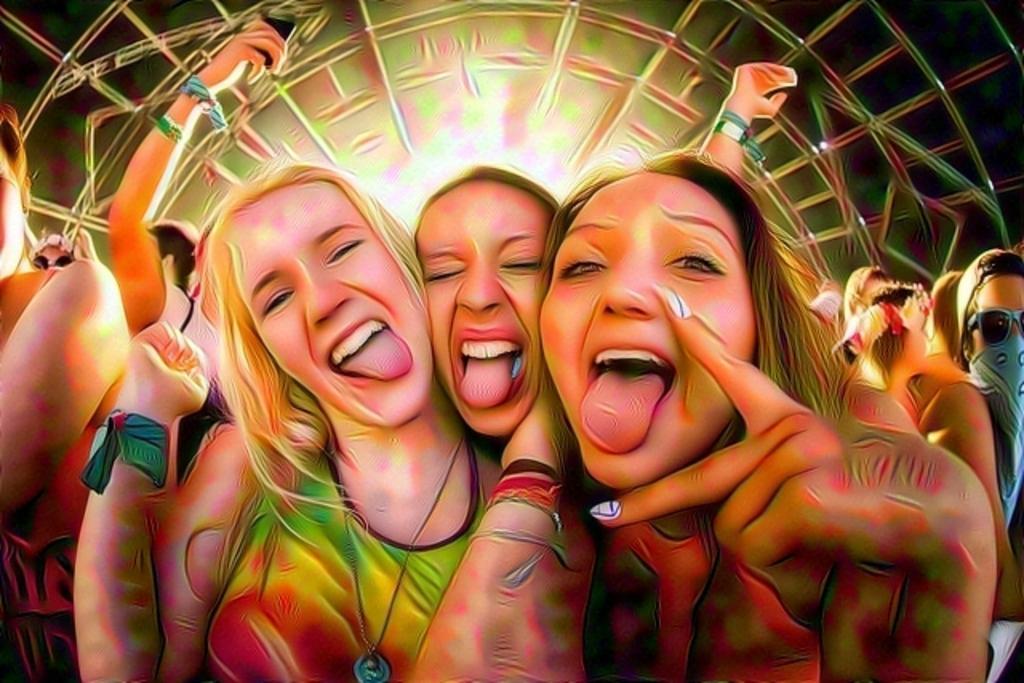Describe this image in one or two sentences. This is an edited image. I can see a group of people. In the background, It looks like a truss. 